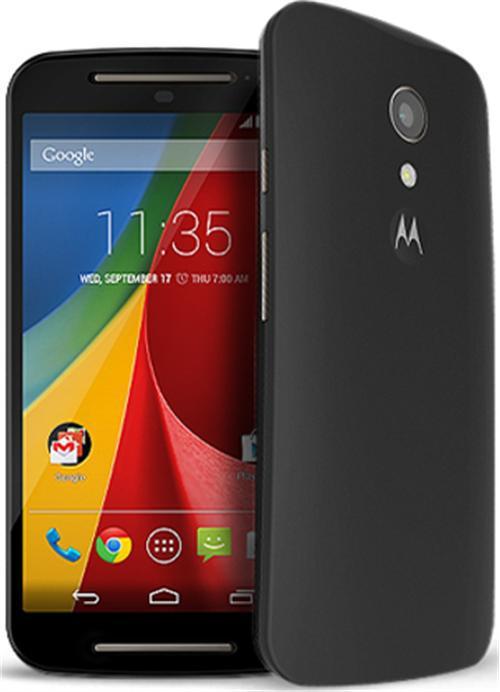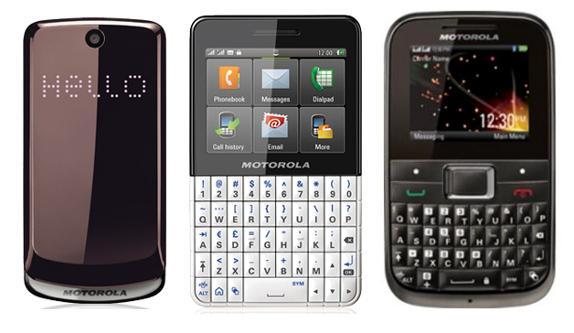The first image is the image on the left, the second image is the image on the right. Assess this claim about the two images: "The right image shows exactly three phones, which are displayed upright and spaced apart instead of overlapping.". Correct or not? Answer yes or no. Yes. The first image is the image on the left, the second image is the image on the right. For the images displayed, is the sentence "The left and right image contains the same number of phones that a vertical." factually correct? Answer yes or no. No. 